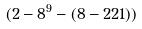<formula> <loc_0><loc_0><loc_500><loc_500>( 2 - 8 ^ { 9 } - ( 8 - 2 2 1 ) )</formula> 